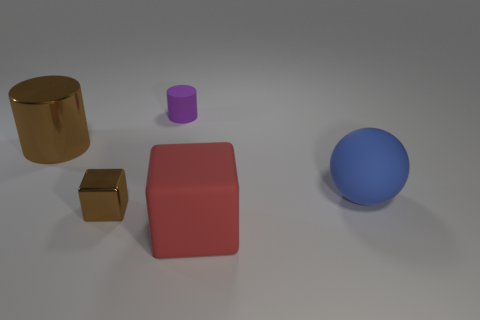Add 3 rubber balls. How many objects exist? 8 Subtract all red blocks. How many blocks are left? 1 Subtract all red cubes. How many green cylinders are left? 0 Subtract all gray shiny cylinders. Subtract all big rubber things. How many objects are left? 3 Add 4 small purple matte cylinders. How many small purple matte cylinders are left? 5 Add 4 large brown metal cylinders. How many large brown metal cylinders exist? 5 Subtract 1 red cubes. How many objects are left? 4 Subtract all cubes. How many objects are left? 3 Subtract 1 blocks. How many blocks are left? 1 Subtract all green cylinders. Subtract all red balls. How many cylinders are left? 2 